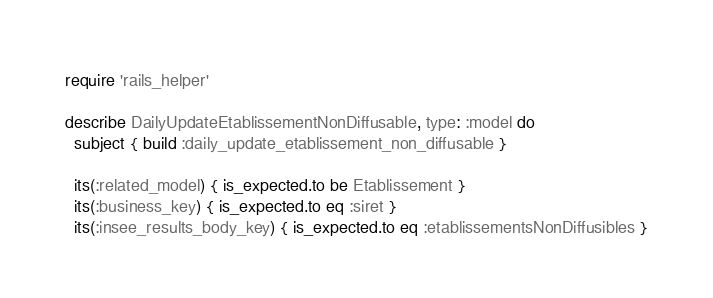Convert code to text. <code><loc_0><loc_0><loc_500><loc_500><_Ruby_>require 'rails_helper'

describe DailyUpdateEtablissementNonDiffusable, type: :model do
  subject { build :daily_update_etablissement_non_diffusable }

  its(:related_model) { is_expected.to be Etablissement }
  its(:business_key) { is_expected.to eq :siret }
  its(:insee_results_body_key) { is_expected.to eq :etablissementsNonDiffusibles }</code> 